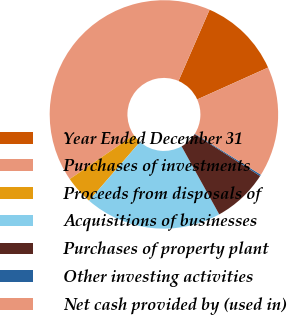Convert chart. <chart><loc_0><loc_0><loc_500><loc_500><pie_chart><fcel>Year Ended December 31<fcel>Purchases of investments<fcel>Proceeds from disposals of<fcel>Acquisitions of businesses<fcel>Purchases of property plant<fcel>Other investing activities<fcel>Net cash provided by (used in)<nl><fcel>11.73%<fcel>41.12%<fcel>4.05%<fcel>19.42%<fcel>7.89%<fcel>0.21%<fcel>15.58%<nl></chart> 